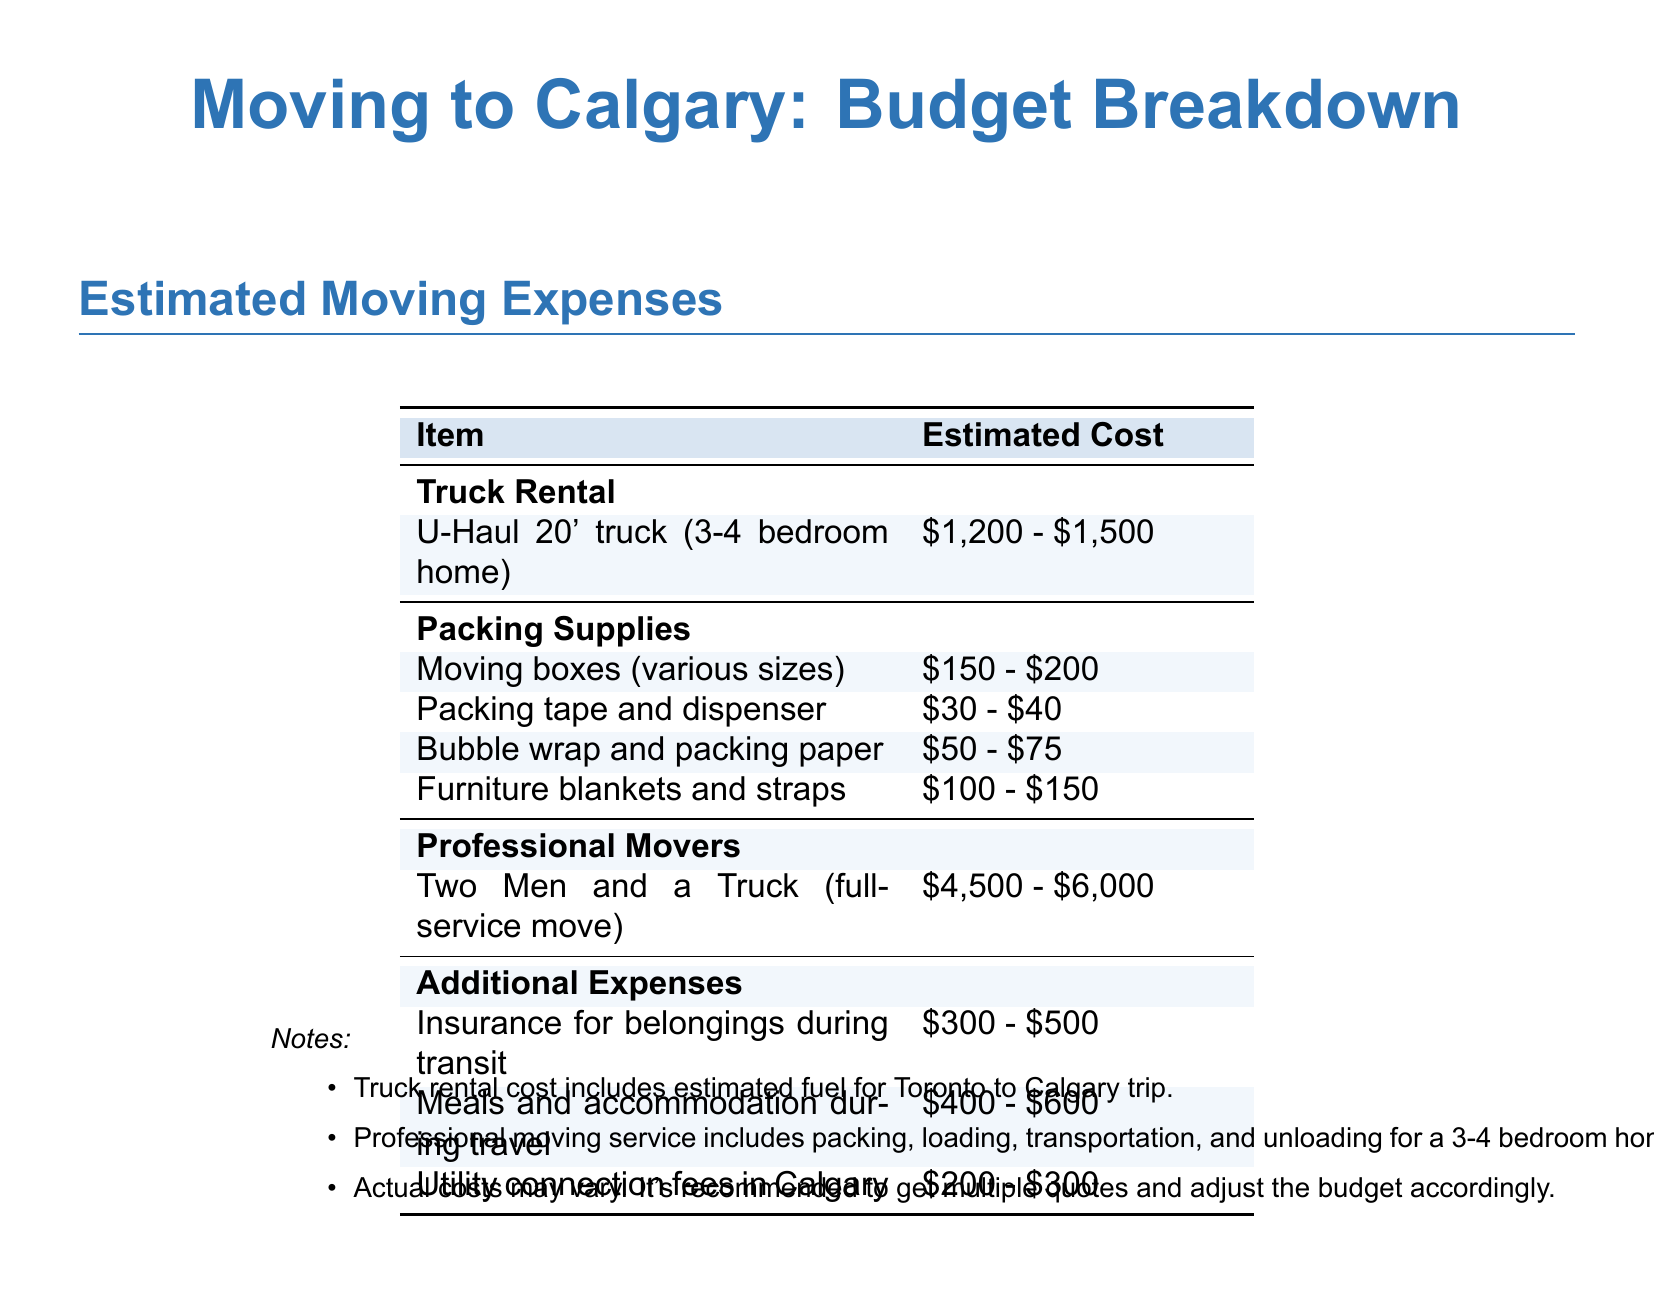What is the estimated cost of a U-Haul 20' truck? The document states that the estimated cost of a U-Haul 20' truck is between $1,200 and $1,500.
Answer: $1,200 - $1,500 What is the cost range for packing tape and dispenser? The document lists the estimated cost for packing tape and dispenser between $30 and $40.
Answer: $30 - $40 How much do professional movers charge for a full-service move? According to the document, professional movers charge between $4,500 and $6,000 for a full-service move.
Answer: $4,500 - $6,000 What is included in the truck rental cost? The document mentions that the truck rental cost includes estimated fuel for the Toronto to Calgary trip.
Answer: Estimated fuel What is the total estimated range for additional expenses? To find the total range, add up the lowest and highest estimates for additional expenses which are $300 to $500 for insurance, $400 to $600 for meals, and $200 to $300 for utility fees, resulting in a total range of $900 to $1,400.
Answer: $900 - $1,400 What is the cost of furniture blankets and straps? The document estimates the cost of furniture blankets and straps to be between $100 and $150.
Answer: $100 - $150 What should one do to adjust the budget accordingly? The document suggests getting multiple quotes to adjust the budget.
Answer: Get multiple quotes What is the estimated cost of moving boxes? The document lists the estimated cost of moving boxes as between $150 and $200.
Answer: $150 - $200 How much is the estimated utility connection fees in Calgary? The document states that utility connection fees in Calgary are estimated to be between $200 and $300.
Answer: $200 - $300 